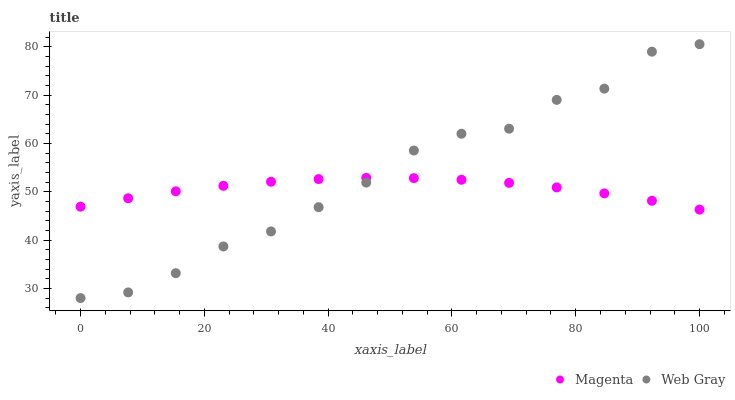Does Magenta have the minimum area under the curve?
Answer yes or no. Yes. Does Web Gray have the maximum area under the curve?
Answer yes or no. Yes. Does Web Gray have the minimum area under the curve?
Answer yes or no. No. Is Magenta the smoothest?
Answer yes or no. Yes. Is Web Gray the roughest?
Answer yes or no. Yes. Is Web Gray the smoothest?
Answer yes or no. No. Does Web Gray have the lowest value?
Answer yes or no. Yes. Does Web Gray have the highest value?
Answer yes or no. Yes. Does Web Gray intersect Magenta?
Answer yes or no. Yes. Is Web Gray less than Magenta?
Answer yes or no. No. Is Web Gray greater than Magenta?
Answer yes or no. No. 